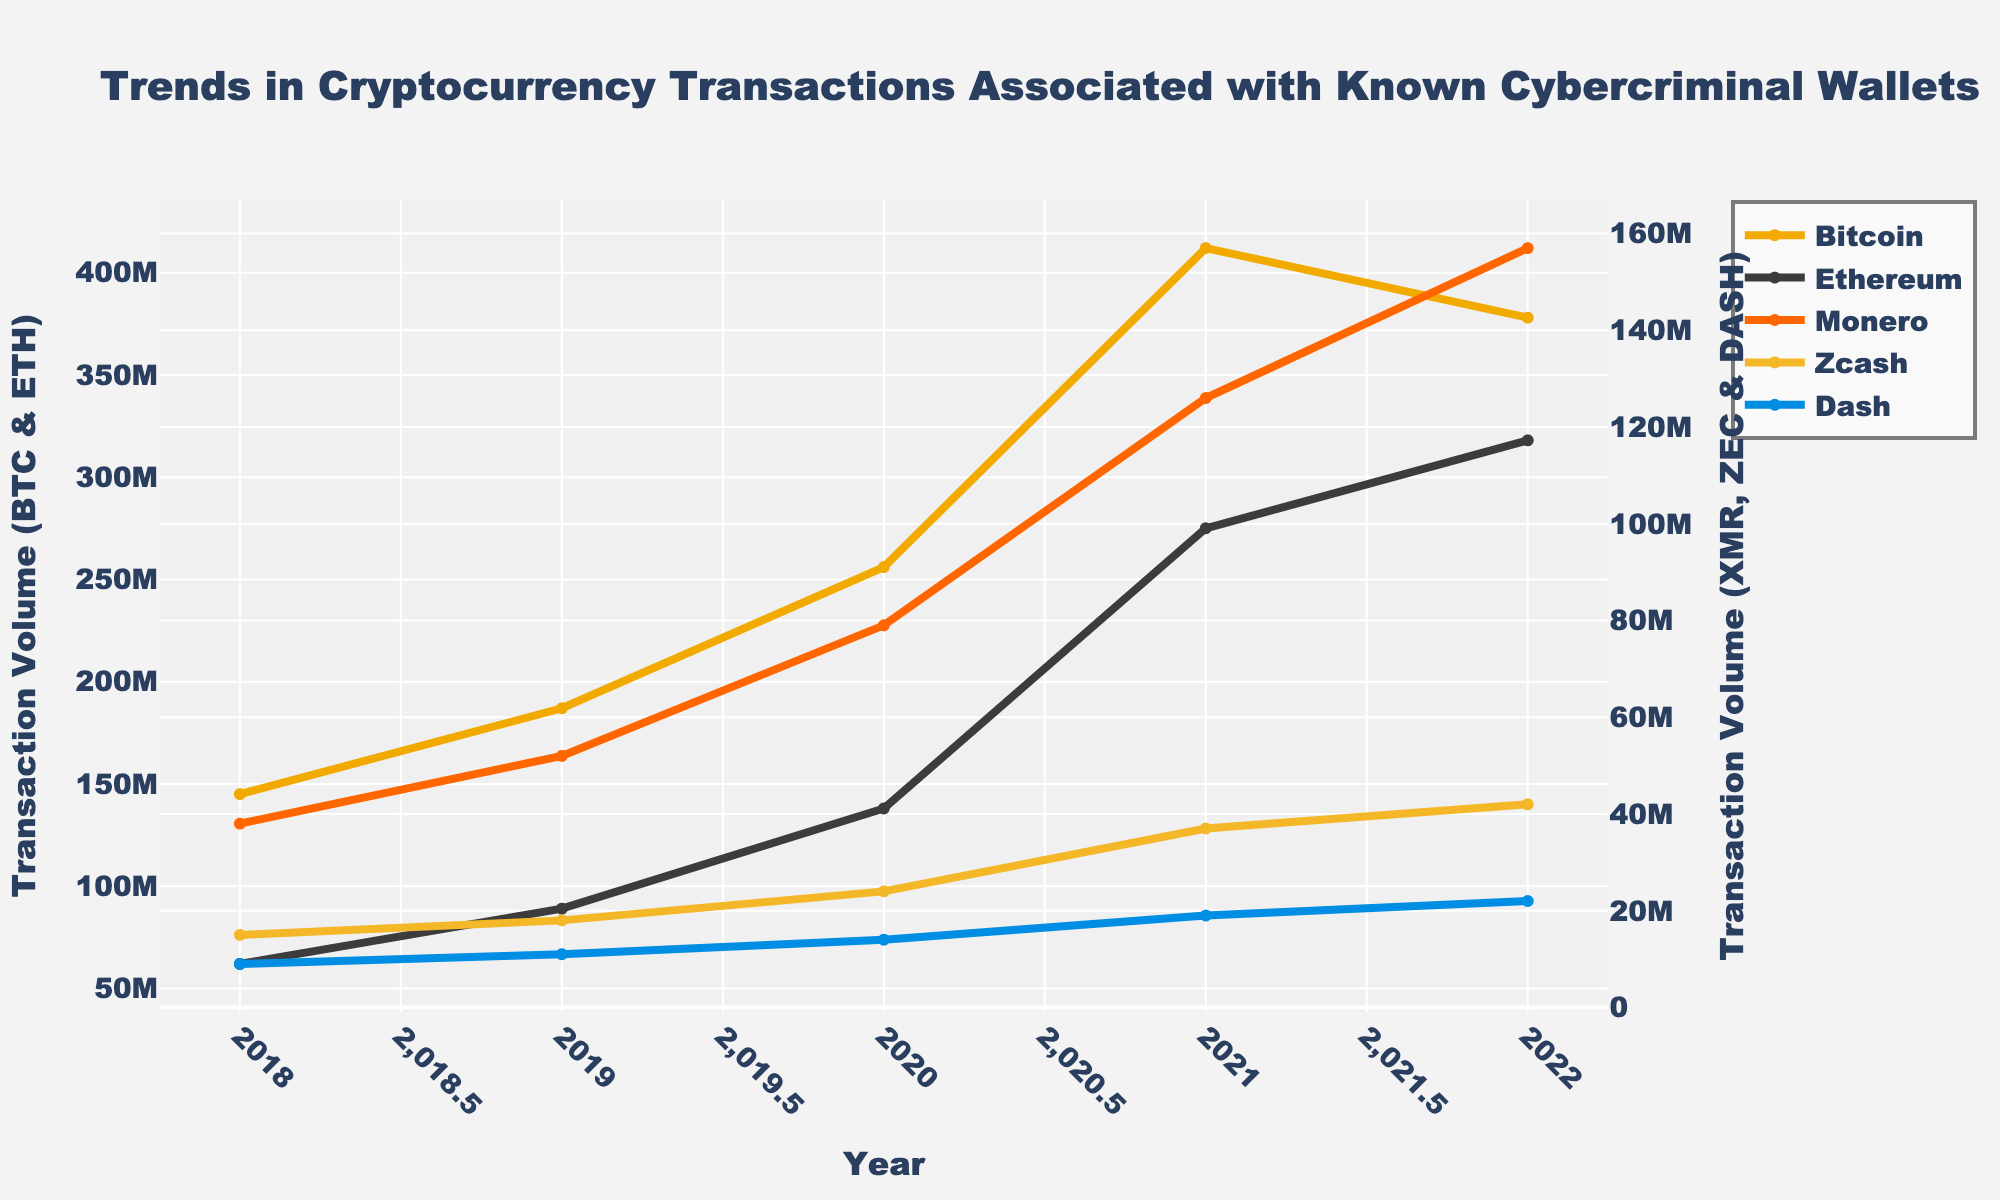what is the overall trend in Bitcoin transactions from 2018 to 2022? The chart shows that Bitcoin transactions consistently increased from 2018 to 2021, peaking at 412 million USD in 2021. There is a notable drop in 2022 to 378 million USD.
Answer: General increase with a decline in 2022 Which cryptocurrency had the highest transaction value in 2022? According to the chart, Ethereum had the highest transaction value in 2022, reaching 318 million USD.
Answer: Ethereum How did the transaction volume of Monero change between 2018 and 2022? Observing the plot, Monero's transaction volume increased each year from 2018 to 2022, rising from 38 million USD to 157 million USD.
Answer: Increased How does the transaction volume of Dash in 2019 compare to Ethereum in the same year? Dash transaction volume was significantly lower compared to Ethereum in 2019. Dash had 11 million USD while Ethereum had 89 million USD.
Answer: Ethereum is higher than Dash What is the cumulative transaction volume of Ethereum from 2018 to 2022? By adding the values from each year: 62 million + 89 million + 138 million + 275 million + 318 million = 882 million USD.
Answer: 882 million USD Which year had the highest total transaction volumes across all cryptocurrencies listed? Summing up the values for each year: 2018 (269 million), 2019 (339 million), 2020 (511 million), 2021 (869 million), 2022 (917 million). The highest is 2022 with 917 million USD.
Answer: 2022 If you combine the transaction volumes of Zcash and Dash in 2018, what is the total? Adding the values for Zcash (15 million USD) and Dash (9 million USD) for the year 2018 gives a total of 24 million USD.
Answer: 24 million USD Which cryptocurrencies had their maximum transaction volume in 2021? Bitcoin (412 million USD), Ethereum (275 million USD), and Monero (126 million USD) all reached their peak transaction volumes in 2021.
Answer: Bitcoin, Ethereum, Monero How much more were Bitcoin transactions in 2020 compared to Monero in the same year? Subtracting Monero's transaction volume (79 million USD) from Bitcoin's (256 million USD) in 2020 gives a difference of 177 million USD.
Answer: 177 million USD By what percentage did Bitcoin's transaction volume increase from 2018 to 2021? The increase is from 145 million USD to 412 million USD. The percentage increase is calculated as ((412 - 145) / 145) * 100 = 184.14%.
Answer: 184.14% 